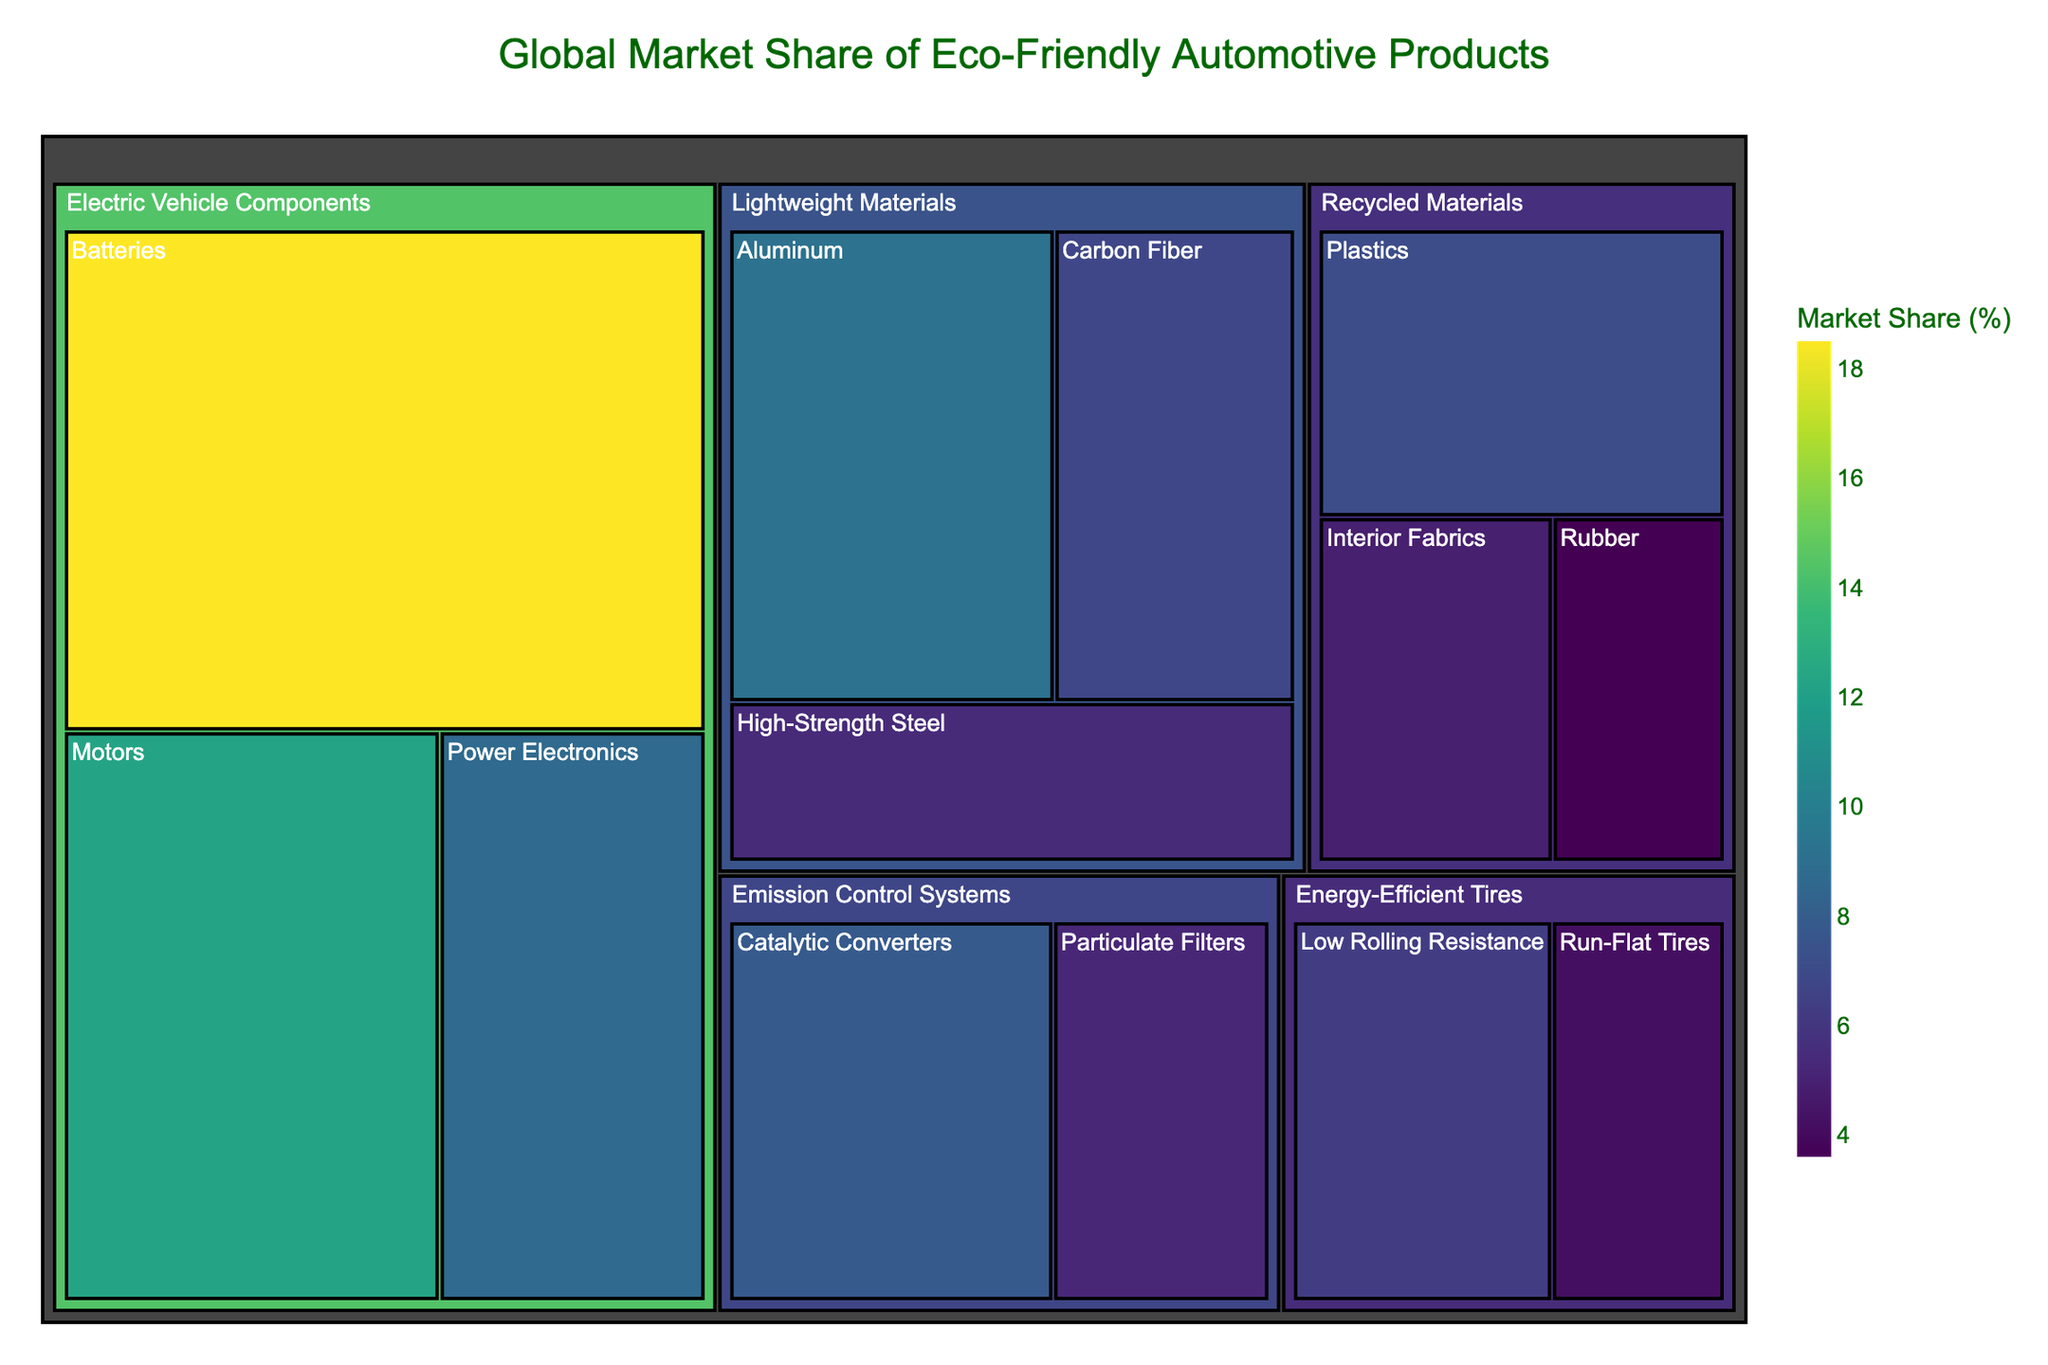What is the title of the treemap? The title is displayed prominently at the top of the treemap. It reads "Global Market Share of Eco-Friendly Automotive Products."
Answer: Global Market Share of Eco-Friendly Automotive Products Which category has the largest market share of eco-friendly automotive products? By looking at the treemap, the category with the largest area represents the largest market share. "Electric Vehicle Components" occupies the largest area.
Answer: Electric Vehicle Components What is the market share of Batteries within Electric Vehicle Components? Batteries are a subcategory under Electric Vehicle Components. The market share for Batteries is shown as "18.5%" on the treemap.
Answer: 18.5% How does the market share of Aluminum compare to that of Carbon Fiber? Both Aluminum and Carbon Fiber are subcategories under Lightweight Materials. Aluminum has a market share of "9.2%" and Carbon Fiber has "6.8%". Comparing these two, Aluminum has a higher market share.
Answer: Aluminum > Carbon Fiber What is the total market share of all subcategories under Recycled Materials? Recycled Materials has three subcategories: Interior Fabrics (4.9%), Plastics (7.1%), and Rubber (3.6%). Summing these percentages, the total market share is 4.9 + 7.1 + 3.6.
Answer: 15.6% Which subcategory in Emission Control Systems has a higher market share? Emission Control Systems include Catalytic Converters and Particulate Filters. Catalytic Converters have "7.8%" and Particulate Filters have "5.2%". Catalytic Converters have a higher market share.
Answer: Catalytic Converters Are there any subcategories with a market share less than 5%? By examining the treemap, subcategories with market shares less than 5% are Carbon Fiber (6.8%), High-Strength Steel (5.4%), Interior Fabrics (4.9%), Rubber (3.6%), and Run-Flat Tires (4.2%).
Answer: Yes What is the average market share of subcategories within Electric Vehicle Components? Electric Vehicle Components include Batteries (18.5%), Motors (12.3%), and Power Electronics (8.7%). Calculating the average: (18.5 + 12.3 + 8.7) / 3 = 13.17%.
Answer: 13.17% Which category has the lowest total market share, and what is it? By comparing the areas representing each category, Recycled Materials appears to have the smallest total market share. Adding the subcategories: 4.9 + 7.1 + 3.6.
Answer: Recycled Materials: 15.6% If the market share of Low Rolling Resistance tires increased by 2%, what would be its new market share? The current market share of Low Rolling Resistance tires is "6.3%". Adding 2% to this: 6.3 + 2.0 = 8.3%.
Answer: 8.3% 